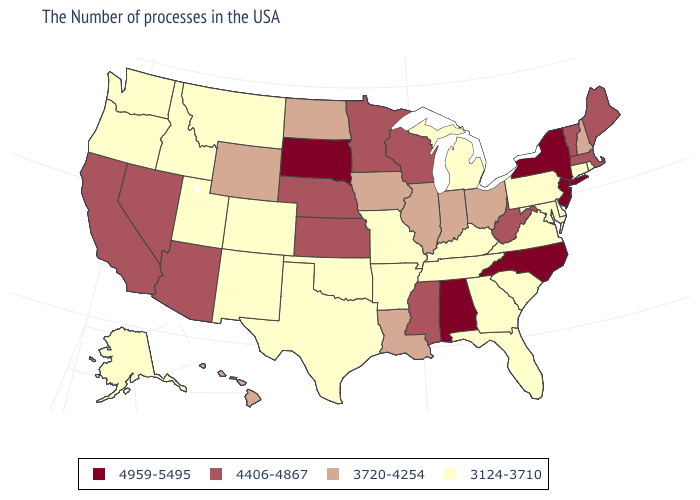Does New Jersey have the highest value in the USA?
Concise answer only. Yes. Which states have the highest value in the USA?
Short answer required. New York, New Jersey, North Carolina, Alabama, South Dakota. Name the states that have a value in the range 4406-4867?
Answer briefly. Maine, Massachusetts, Vermont, West Virginia, Wisconsin, Mississippi, Minnesota, Kansas, Nebraska, Arizona, Nevada, California. What is the value of North Dakota?
Keep it brief. 3720-4254. What is the value of Rhode Island?
Give a very brief answer. 3124-3710. What is the value of Kentucky?
Answer briefly. 3124-3710. What is the lowest value in states that border Michigan?
Short answer required. 3720-4254. Name the states that have a value in the range 4959-5495?
Quick response, please. New York, New Jersey, North Carolina, Alabama, South Dakota. Does the first symbol in the legend represent the smallest category?
Short answer required. No. Among the states that border Ohio , which have the lowest value?
Answer briefly. Pennsylvania, Michigan, Kentucky. Does Arizona have the highest value in the West?
Be succinct. Yes. Which states have the highest value in the USA?
Keep it brief. New York, New Jersey, North Carolina, Alabama, South Dakota. What is the value of Ohio?
Answer briefly. 3720-4254. Name the states that have a value in the range 3720-4254?
Be succinct. New Hampshire, Ohio, Indiana, Illinois, Louisiana, Iowa, North Dakota, Wyoming, Hawaii. 